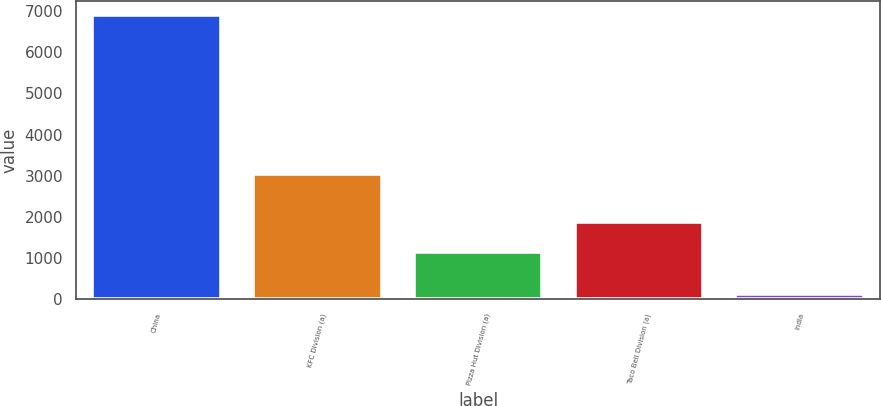Convert chart. <chart><loc_0><loc_0><loc_500><loc_500><bar_chart><fcel>China<fcel>KFC Division (a)<fcel>Pizza Hut Division (a)<fcel>Taco Bell Division (a)<fcel>India<nl><fcel>6905<fcel>3036<fcel>1147<fcel>1869<fcel>127<nl></chart> 